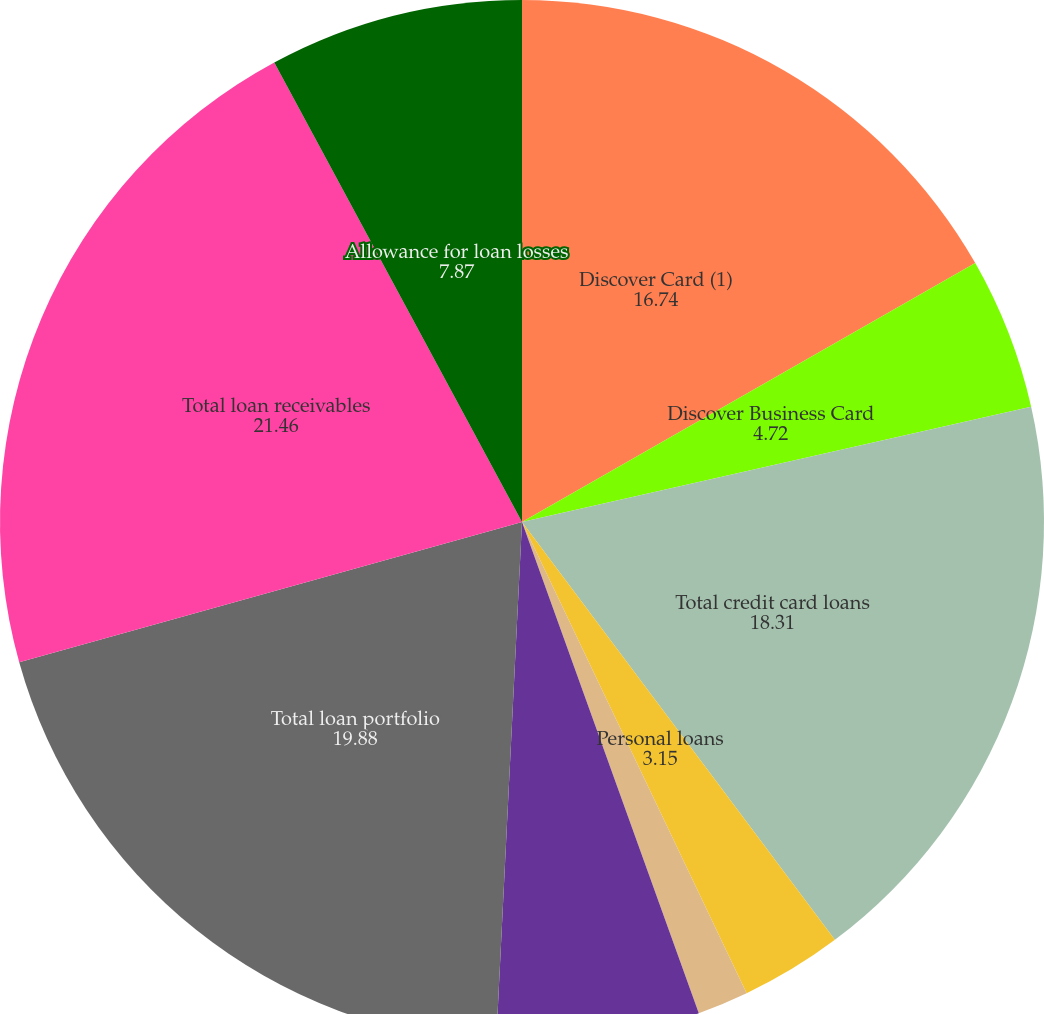Convert chart to OTSL. <chart><loc_0><loc_0><loc_500><loc_500><pie_chart><fcel>Discover Card (1)<fcel>Discover Business Card<fcel>Total credit card loans<fcel>Personal loans<fcel>Private student loans<fcel>Other<fcel>Total other consumer loans<fcel>Total loan portfolio<fcel>Total loan receivables<fcel>Allowance for loan losses<nl><fcel>16.74%<fcel>4.72%<fcel>18.31%<fcel>3.15%<fcel>0.0%<fcel>1.58%<fcel>6.29%<fcel>19.88%<fcel>21.46%<fcel>7.87%<nl></chart> 